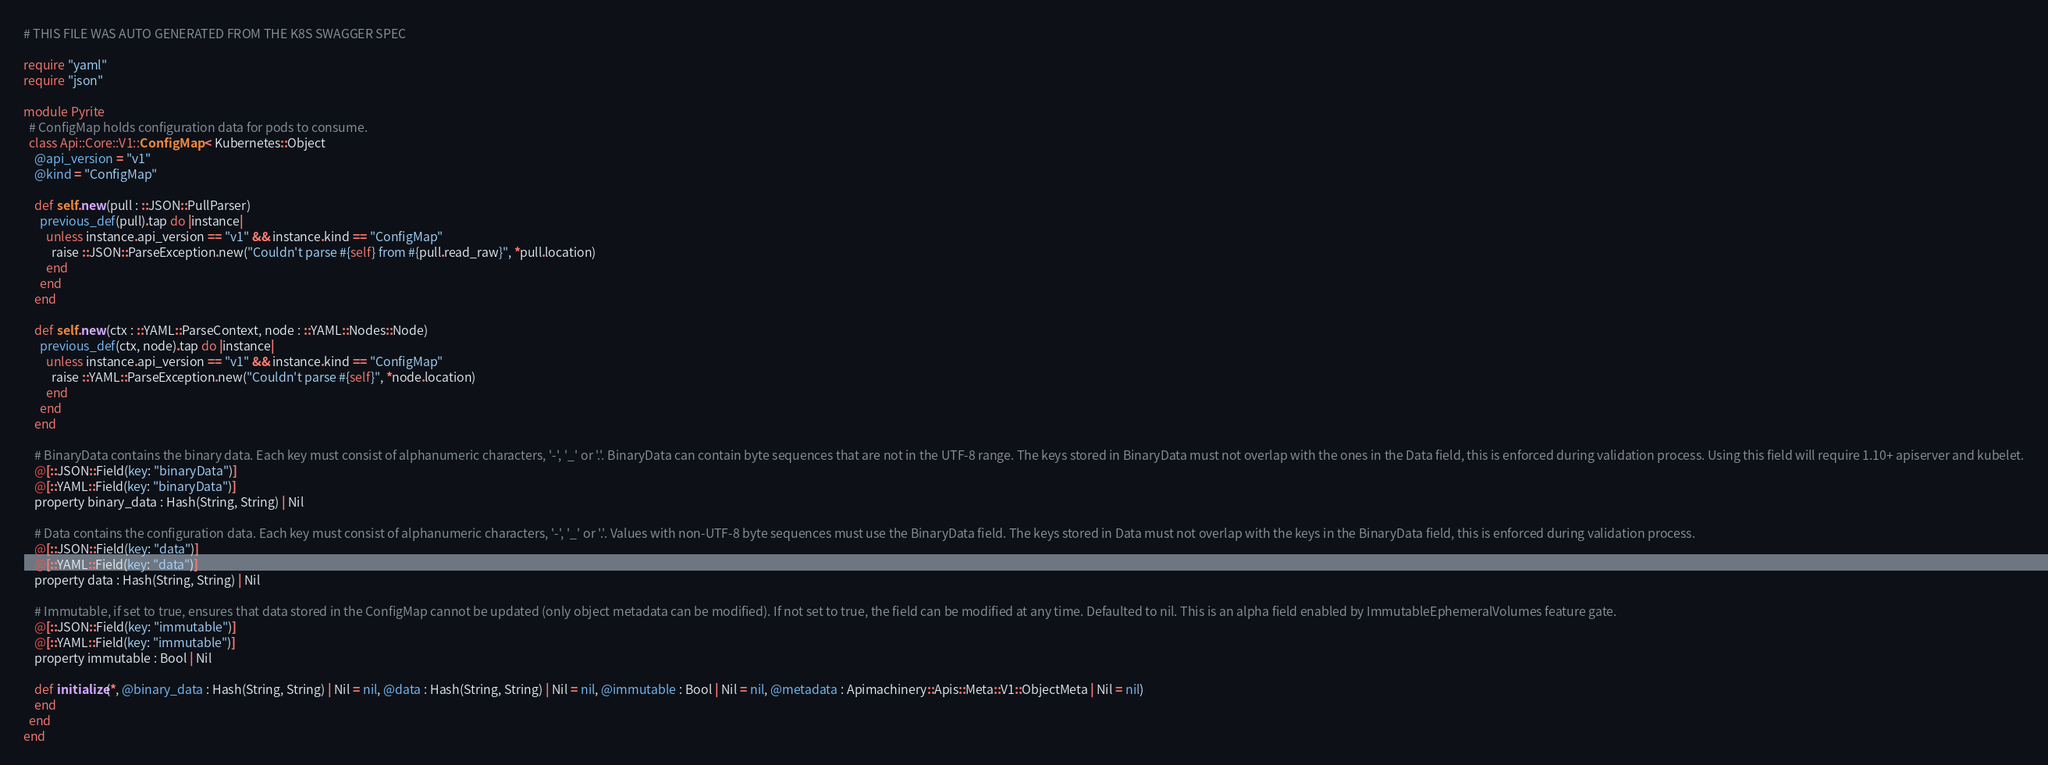<code> <loc_0><loc_0><loc_500><loc_500><_Crystal_># THIS FILE WAS AUTO GENERATED FROM THE K8S SWAGGER SPEC

require "yaml"
require "json"

module Pyrite
  # ConfigMap holds configuration data for pods to consume.
  class Api::Core::V1::ConfigMap < Kubernetes::Object
    @api_version = "v1"
    @kind = "ConfigMap"

    def self.new(pull : ::JSON::PullParser)
      previous_def(pull).tap do |instance|
        unless instance.api_version == "v1" && instance.kind == "ConfigMap"
          raise ::JSON::ParseException.new("Couldn't parse #{self} from #{pull.read_raw}", *pull.location)
        end
      end
    end

    def self.new(ctx : ::YAML::ParseContext, node : ::YAML::Nodes::Node)
      previous_def(ctx, node).tap do |instance|
        unless instance.api_version == "v1" && instance.kind == "ConfigMap"
          raise ::YAML::ParseException.new("Couldn't parse #{self}", *node.location)
        end
      end
    end

    # BinaryData contains the binary data. Each key must consist of alphanumeric characters, '-', '_' or '.'. BinaryData can contain byte sequences that are not in the UTF-8 range. The keys stored in BinaryData must not overlap with the ones in the Data field, this is enforced during validation process. Using this field will require 1.10+ apiserver and kubelet.
    @[::JSON::Field(key: "binaryData")]
    @[::YAML::Field(key: "binaryData")]
    property binary_data : Hash(String, String) | Nil

    # Data contains the configuration data. Each key must consist of alphanumeric characters, '-', '_' or '.'. Values with non-UTF-8 byte sequences must use the BinaryData field. The keys stored in Data must not overlap with the keys in the BinaryData field, this is enforced during validation process.
    @[::JSON::Field(key: "data")]
    @[::YAML::Field(key: "data")]
    property data : Hash(String, String) | Nil

    # Immutable, if set to true, ensures that data stored in the ConfigMap cannot be updated (only object metadata can be modified). If not set to true, the field can be modified at any time. Defaulted to nil. This is an alpha field enabled by ImmutableEphemeralVolumes feature gate.
    @[::JSON::Field(key: "immutable")]
    @[::YAML::Field(key: "immutable")]
    property immutable : Bool | Nil

    def initialize(*, @binary_data : Hash(String, String) | Nil = nil, @data : Hash(String, String) | Nil = nil, @immutable : Bool | Nil = nil, @metadata : Apimachinery::Apis::Meta::V1::ObjectMeta | Nil = nil)
    end
  end
end
</code> 